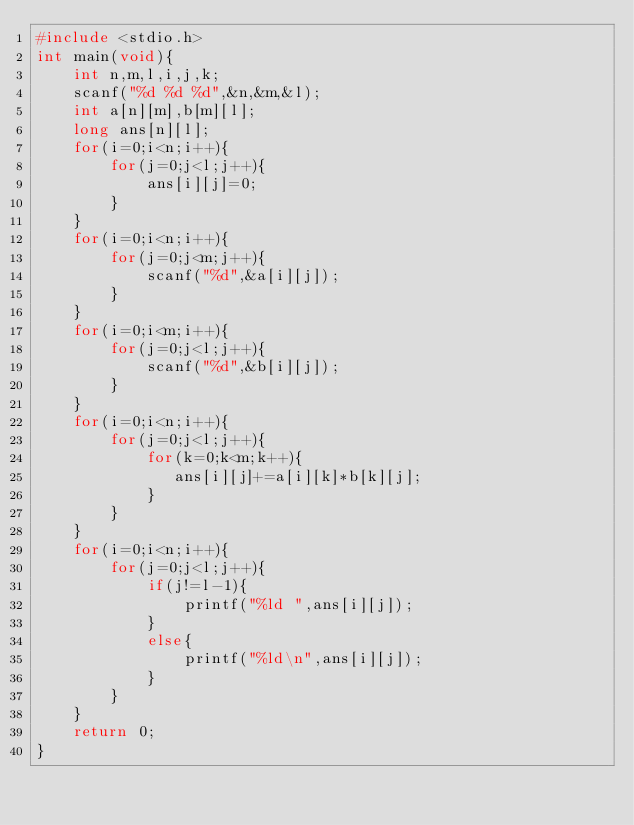<code> <loc_0><loc_0><loc_500><loc_500><_C_>#include <stdio.h>
int main(void){
    int n,m,l,i,j,k;
    scanf("%d %d %d",&n,&m,&l);
    int a[n][m],b[m][l];
    long ans[n][l];
    for(i=0;i<n;i++){
        for(j=0;j<l;j++){
            ans[i][j]=0;
        }
    }
    for(i=0;i<n;i++){
        for(j=0;j<m;j++){
            scanf("%d",&a[i][j]);
        }
    }
    for(i=0;i<m;i++){
        for(j=0;j<l;j++){
            scanf("%d",&b[i][j]);
        }
    }
    for(i=0;i<n;i++){
        for(j=0;j<l;j++){
            for(k=0;k<m;k++){
               ans[i][j]+=a[i][k]*b[k][j]; 
            }
        }
    }
    for(i=0;i<n;i++){
        for(j=0;j<l;j++){
            if(j!=l-1){
                printf("%ld ",ans[i][j]);
            }
            else{
                printf("%ld\n",ans[i][j]);
            }
        }
    }
    return 0;
}

</code> 